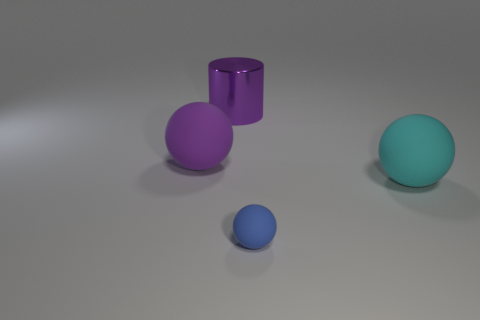Subtract all large matte spheres. How many spheres are left? 1 Add 2 small yellow rubber cylinders. How many objects exist? 6 Subtract all brown balls. Subtract all yellow cylinders. How many balls are left? 3 Subtract all cylinders. How many objects are left? 3 Add 4 rubber objects. How many rubber objects are left? 7 Add 3 tiny matte balls. How many tiny matte balls exist? 4 Subtract 0 cyan blocks. How many objects are left? 4 Subtract all big purple objects. Subtract all blue balls. How many objects are left? 1 